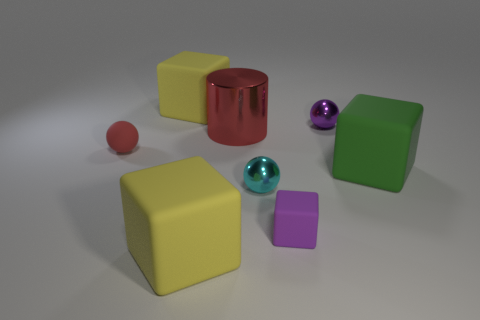Is there anything else that is the same shape as the red shiny thing?
Make the answer very short. No. There is a tiny object that is the same color as the cylinder; what is its material?
Your answer should be very brief. Rubber. What is the material of the small sphere that is to the left of the yellow matte cube behind the large green block?
Give a very brief answer. Rubber. Is there another sphere made of the same material as the purple ball?
Offer a terse response. Yes. There is a red ball that is the same size as the purple matte object; what is its material?
Give a very brief answer. Rubber. How big is the yellow matte cube in front of the big object that is behind the red shiny thing that is behind the red matte sphere?
Ensure brevity in your answer.  Large. Is there a yellow matte thing right of the yellow matte thing that is in front of the cyan sphere?
Provide a short and direct response. No. There is a red rubber thing; is it the same shape as the purple thing behind the green matte block?
Keep it short and to the point. Yes. The rubber ball that is on the left side of the large shiny cylinder is what color?
Make the answer very short. Red. There is a yellow matte cube that is behind the small metal sphere that is behind the large red metal object; what is its size?
Offer a very short reply. Large. 